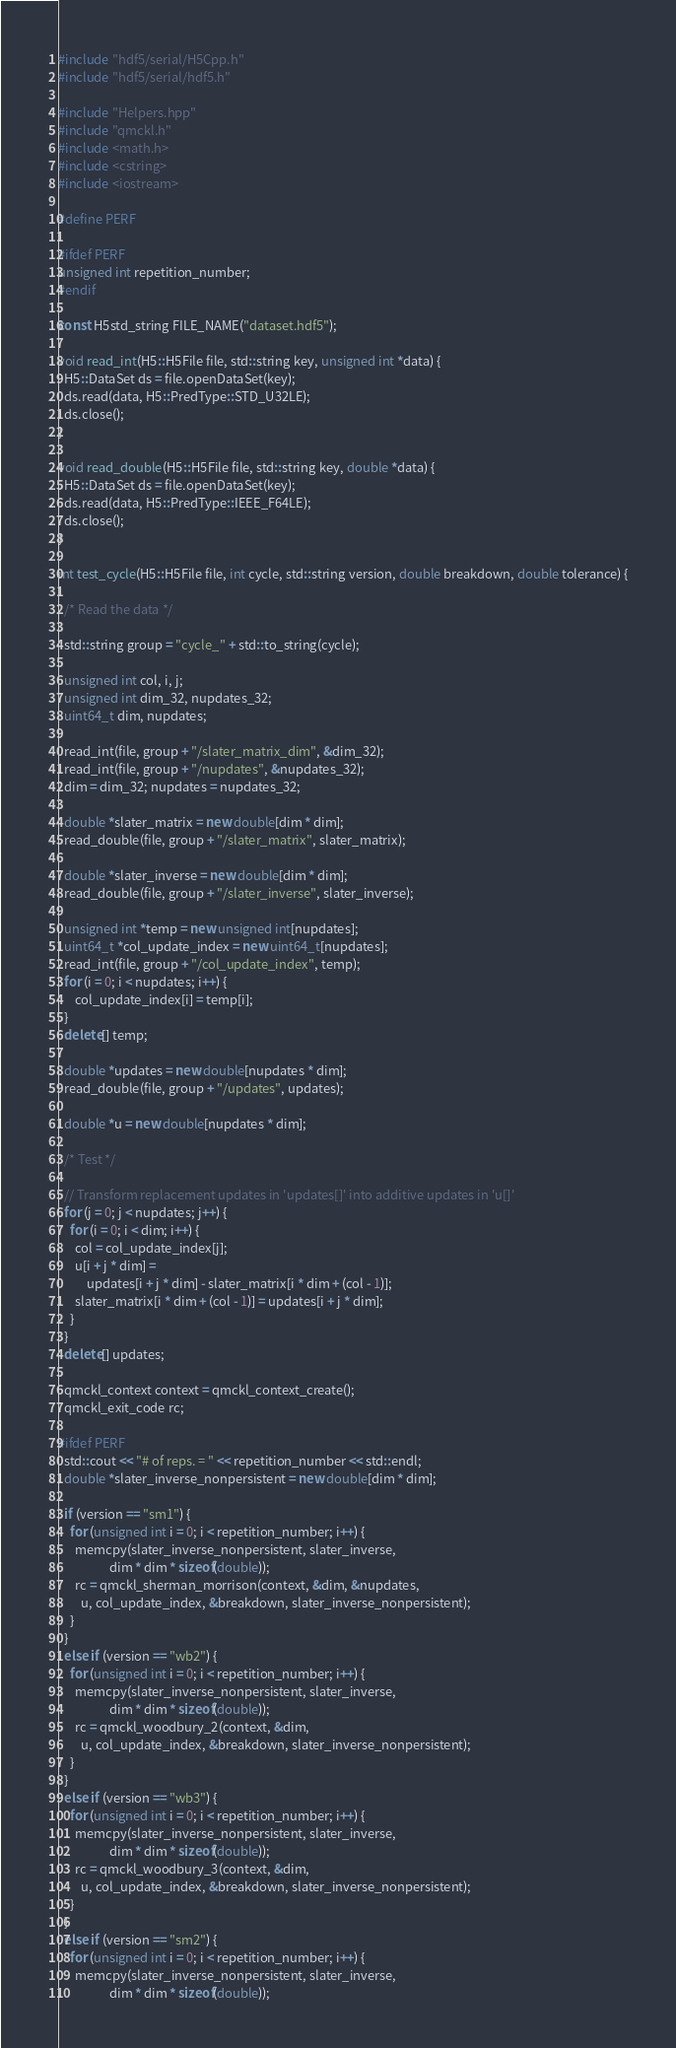<code> <loc_0><loc_0><loc_500><loc_500><_C++_>#include "hdf5/serial/H5Cpp.h"
#include "hdf5/serial/hdf5.h"

#include "Helpers.hpp"
#include "qmckl.h"
#include <math.h>
#include <cstring>
#include <iostream>

#define PERF

#ifdef PERF
unsigned int repetition_number;
#endif

const H5std_string FILE_NAME("dataset.hdf5");

void read_int(H5::H5File file, std::string key, unsigned int *data) {
  H5::DataSet ds = file.openDataSet(key);
  ds.read(data, H5::PredType::STD_U32LE);
  ds.close();
}

void read_double(H5::H5File file, std::string key, double *data) {
  H5::DataSet ds = file.openDataSet(key);
  ds.read(data, H5::PredType::IEEE_F64LE);
  ds.close();
}

int test_cycle(H5::H5File file, int cycle, std::string version, double breakdown, double tolerance) {

  /* Read the data */

  std::string group = "cycle_" + std::to_string(cycle);

  unsigned int col, i, j;
  unsigned int dim_32, nupdates_32;
  uint64_t dim, nupdates;

  read_int(file, group + "/slater_matrix_dim", &dim_32);
  read_int(file, group + "/nupdates", &nupdates_32);
  dim = dim_32; nupdates = nupdates_32;

  double *slater_matrix = new double[dim * dim];
  read_double(file, group + "/slater_matrix", slater_matrix);

  double *slater_inverse = new double[dim * dim];
  read_double(file, group + "/slater_inverse", slater_inverse);

  unsigned int *temp = new unsigned int[nupdates];
  uint64_t *col_update_index = new uint64_t[nupdates];
  read_int(file, group + "/col_update_index", temp);
  for (i = 0; i < nupdates; i++) {
	  col_update_index[i] = temp[i];
  }
  delete[] temp;

  double *updates = new double[nupdates * dim];
  read_double(file, group + "/updates", updates);

  double *u = new double[nupdates * dim];

  /* Test */

  // Transform replacement updates in 'updates[]' into additive updates in 'u[]'
  for (j = 0; j < nupdates; j++) {
    for (i = 0; i < dim; i++) {
      col = col_update_index[j];
      u[i + j * dim] =
          updates[i + j * dim] - slater_matrix[i * dim + (col - 1)];
      slater_matrix[i * dim + (col - 1)] = updates[i + j * dim];
    }
  }
  delete[] updates;

  qmckl_context context = qmckl_context_create();
  qmckl_exit_code rc;

#ifdef PERF
  std::cout << "# of reps. = " << repetition_number << std::endl;
  double *slater_inverse_nonpersistent = new double[dim * dim];

  if (version == "sm1") {
    for (unsigned int i = 0; i < repetition_number; i++) {
      memcpy(slater_inverse_nonpersistent, slater_inverse,
                  dim * dim * sizeof(double));
      rc = qmckl_sherman_morrison(context, &dim, &nupdates,
        u, col_update_index, &breakdown, slater_inverse_nonpersistent);
    }
  }
  else if (version == "wb2") {
    for (unsigned int i = 0; i < repetition_number; i++) {
      memcpy(slater_inverse_nonpersistent, slater_inverse,
                  dim * dim * sizeof(double));
      rc = qmckl_woodbury_2(context, &dim,
        u, col_update_index, &breakdown, slater_inverse_nonpersistent);
    }
  }
  else if (version == "wb3") {
    for (unsigned int i = 0; i < repetition_number; i++) {
      memcpy(slater_inverse_nonpersistent, slater_inverse,
                  dim * dim * sizeof(double));
      rc = qmckl_woodbury_3(context, &dim,
        u, col_update_index, &breakdown, slater_inverse_nonpersistent);
    }
  }
  else if (version == "sm2") {
    for (unsigned int i = 0; i < repetition_number; i++) {
      memcpy(slater_inverse_nonpersistent, slater_inverse,
                  dim * dim * sizeof(double));</code> 